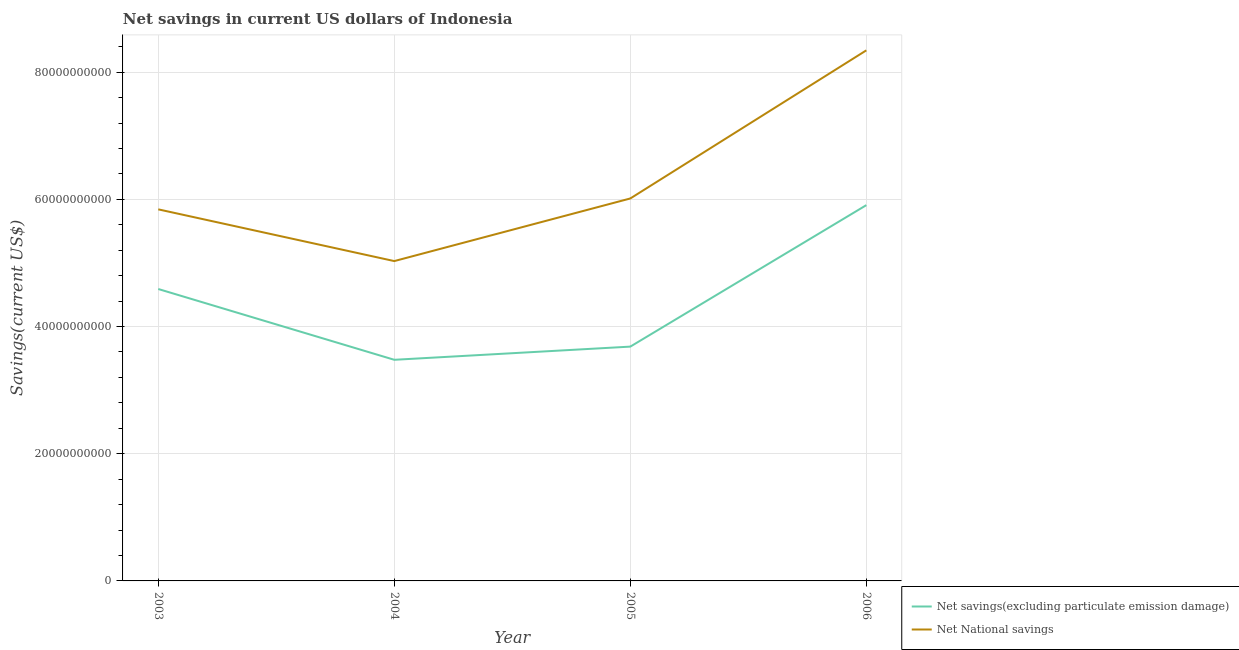Is the number of lines equal to the number of legend labels?
Offer a terse response. Yes. What is the net national savings in 2003?
Ensure brevity in your answer.  5.84e+1. Across all years, what is the maximum net national savings?
Ensure brevity in your answer.  8.34e+1. Across all years, what is the minimum net savings(excluding particulate emission damage)?
Your answer should be very brief. 3.48e+1. In which year was the net savings(excluding particulate emission damage) maximum?
Give a very brief answer. 2006. What is the total net national savings in the graph?
Offer a terse response. 2.52e+11. What is the difference between the net national savings in 2003 and that in 2006?
Give a very brief answer. -2.50e+1. What is the difference between the net national savings in 2005 and the net savings(excluding particulate emission damage) in 2006?
Keep it short and to the point. 1.05e+09. What is the average net national savings per year?
Ensure brevity in your answer.  6.31e+1. In the year 2004, what is the difference between the net national savings and net savings(excluding particulate emission damage)?
Offer a terse response. 1.55e+1. In how many years, is the net national savings greater than 56000000000 US$?
Offer a terse response. 3. What is the ratio of the net savings(excluding particulate emission damage) in 2005 to that in 2006?
Offer a terse response. 0.62. Is the net savings(excluding particulate emission damage) in 2005 less than that in 2006?
Make the answer very short. Yes. What is the difference between the highest and the second highest net national savings?
Offer a very short reply. 2.33e+1. What is the difference between the highest and the lowest net national savings?
Your response must be concise. 3.31e+1. In how many years, is the net national savings greater than the average net national savings taken over all years?
Offer a very short reply. 1. Is the sum of the net savings(excluding particulate emission damage) in 2003 and 2006 greater than the maximum net national savings across all years?
Provide a succinct answer. Yes. How many lines are there?
Ensure brevity in your answer.  2. What is the difference between two consecutive major ticks on the Y-axis?
Give a very brief answer. 2.00e+1. Does the graph contain any zero values?
Make the answer very short. No. How many legend labels are there?
Offer a terse response. 2. How are the legend labels stacked?
Your response must be concise. Vertical. What is the title of the graph?
Keep it short and to the point. Net savings in current US dollars of Indonesia. Does "Domestic liabilities" appear as one of the legend labels in the graph?
Keep it short and to the point. No. What is the label or title of the Y-axis?
Your response must be concise. Savings(current US$). What is the Savings(current US$) of Net savings(excluding particulate emission damage) in 2003?
Your answer should be compact. 4.59e+1. What is the Savings(current US$) of Net National savings in 2003?
Keep it short and to the point. 5.84e+1. What is the Savings(current US$) of Net savings(excluding particulate emission damage) in 2004?
Keep it short and to the point. 3.48e+1. What is the Savings(current US$) in Net National savings in 2004?
Your response must be concise. 5.03e+1. What is the Savings(current US$) in Net savings(excluding particulate emission damage) in 2005?
Your response must be concise. 3.68e+1. What is the Savings(current US$) in Net National savings in 2005?
Your answer should be very brief. 6.01e+1. What is the Savings(current US$) in Net savings(excluding particulate emission damage) in 2006?
Keep it short and to the point. 5.91e+1. What is the Savings(current US$) of Net National savings in 2006?
Make the answer very short. 8.34e+1. Across all years, what is the maximum Savings(current US$) in Net savings(excluding particulate emission damage)?
Offer a terse response. 5.91e+1. Across all years, what is the maximum Savings(current US$) in Net National savings?
Offer a terse response. 8.34e+1. Across all years, what is the minimum Savings(current US$) in Net savings(excluding particulate emission damage)?
Ensure brevity in your answer.  3.48e+1. Across all years, what is the minimum Savings(current US$) of Net National savings?
Your response must be concise. 5.03e+1. What is the total Savings(current US$) in Net savings(excluding particulate emission damage) in the graph?
Make the answer very short. 1.77e+11. What is the total Savings(current US$) of Net National savings in the graph?
Offer a terse response. 2.52e+11. What is the difference between the Savings(current US$) in Net savings(excluding particulate emission damage) in 2003 and that in 2004?
Give a very brief answer. 1.11e+1. What is the difference between the Savings(current US$) in Net National savings in 2003 and that in 2004?
Ensure brevity in your answer.  8.14e+09. What is the difference between the Savings(current US$) of Net savings(excluding particulate emission damage) in 2003 and that in 2005?
Offer a terse response. 9.06e+09. What is the difference between the Savings(current US$) in Net National savings in 2003 and that in 2005?
Give a very brief answer. -1.71e+09. What is the difference between the Savings(current US$) of Net savings(excluding particulate emission damage) in 2003 and that in 2006?
Make the answer very short. -1.32e+1. What is the difference between the Savings(current US$) in Net National savings in 2003 and that in 2006?
Ensure brevity in your answer.  -2.50e+1. What is the difference between the Savings(current US$) in Net savings(excluding particulate emission damage) in 2004 and that in 2005?
Offer a very short reply. -2.07e+09. What is the difference between the Savings(current US$) in Net National savings in 2004 and that in 2005?
Ensure brevity in your answer.  -9.85e+09. What is the difference between the Savings(current US$) in Net savings(excluding particulate emission damage) in 2004 and that in 2006?
Your answer should be very brief. -2.43e+1. What is the difference between the Savings(current US$) in Net National savings in 2004 and that in 2006?
Provide a succinct answer. -3.31e+1. What is the difference between the Savings(current US$) of Net savings(excluding particulate emission damage) in 2005 and that in 2006?
Your answer should be very brief. -2.22e+1. What is the difference between the Savings(current US$) in Net National savings in 2005 and that in 2006?
Ensure brevity in your answer.  -2.33e+1. What is the difference between the Savings(current US$) of Net savings(excluding particulate emission damage) in 2003 and the Savings(current US$) of Net National savings in 2004?
Provide a short and direct response. -4.39e+09. What is the difference between the Savings(current US$) in Net savings(excluding particulate emission damage) in 2003 and the Savings(current US$) in Net National savings in 2005?
Make the answer very short. -1.42e+1. What is the difference between the Savings(current US$) of Net savings(excluding particulate emission damage) in 2003 and the Savings(current US$) of Net National savings in 2006?
Give a very brief answer. -3.75e+1. What is the difference between the Savings(current US$) of Net savings(excluding particulate emission damage) in 2004 and the Savings(current US$) of Net National savings in 2005?
Provide a short and direct response. -2.54e+1. What is the difference between the Savings(current US$) in Net savings(excluding particulate emission damage) in 2004 and the Savings(current US$) in Net National savings in 2006?
Offer a terse response. -4.87e+1. What is the difference between the Savings(current US$) in Net savings(excluding particulate emission damage) in 2005 and the Savings(current US$) in Net National savings in 2006?
Your answer should be compact. -4.66e+1. What is the average Savings(current US$) in Net savings(excluding particulate emission damage) per year?
Ensure brevity in your answer.  4.42e+1. What is the average Savings(current US$) of Net National savings per year?
Make the answer very short. 6.31e+1. In the year 2003, what is the difference between the Savings(current US$) in Net savings(excluding particulate emission damage) and Savings(current US$) in Net National savings?
Your response must be concise. -1.25e+1. In the year 2004, what is the difference between the Savings(current US$) in Net savings(excluding particulate emission damage) and Savings(current US$) in Net National savings?
Offer a terse response. -1.55e+1. In the year 2005, what is the difference between the Savings(current US$) in Net savings(excluding particulate emission damage) and Savings(current US$) in Net National savings?
Your answer should be compact. -2.33e+1. In the year 2006, what is the difference between the Savings(current US$) in Net savings(excluding particulate emission damage) and Savings(current US$) in Net National savings?
Make the answer very short. -2.43e+1. What is the ratio of the Savings(current US$) of Net savings(excluding particulate emission damage) in 2003 to that in 2004?
Your answer should be compact. 1.32. What is the ratio of the Savings(current US$) of Net National savings in 2003 to that in 2004?
Offer a terse response. 1.16. What is the ratio of the Savings(current US$) in Net savings(excluding particulate emission damage) in 2003 to that in 2005?
Provide a short and direct response. 1.25. What is the ratio of the Savings(current US$) of Net National savings in 2003 to that in 2005?
Offer a very short reply. 0.97. What is the ratio of the Savings(current US$) of Net savings(excluding particulate emission damage) in 2003 to that in 2006?
Give a very brief answer. 0.78. What is the ratio of the Savings(current US$) of Net National savings in 2003 to that in 2006?
Ensure brevity in your answer.  0.7. What is the ratio of the Savings(current US$) of Net savings(excluding particulate emission damage) in 2004 to that in 2005?
Your response must be concise. 0.94. What is the ratio of the Savings(current US$) in Net National savings in 2004 to that in 2005?
Provide a succinct answer. 0.84. What is the ratio of the Savings(current US$) in Net savings(excluding particulate emission damage) in 2004 to that in 2006?
Make the answer very short. 0.59. What is the ratio of the Savings(current US$) of Net National savings in 2004 to that in 2006?
Make the answer very short. 0.6. What is the ratio of the Savings(current US$) in Net savings(excluding particulate emission damage) in 2005 to that in 2006?
Your response must be concise. 0.62. What is the ratio of the Savings(current US$) of Net National savings in 2005 to that in 2006?
Offer a very short reply. 0.72. What is the difference between the highest and the second highest Savings(current US$) of Net savings(excluding particulate emission damage)?
Offer a terse response. 1.32e+1. What is the difference between the highest and the second highest Savings(current US$) in Net National savings?
Ensure brevity in your answer.  2.33e+1. What is the difference between the highest and the lowest Savings(current US$) of Net savings(excluding particulate emission damage)?
Your answer should be compact. 2.43e+1. What is the difference between the highest and the lowest Savings(current US$) of Net National savings?
Your response must be concise. 3.31e+1. 